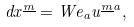Convert formula to latex. <formula><loc_0><loc_0><loc_500><loc_500>d x ^ { \underline { m } } = W e _ { a } u ^ { { \underline { m } } a } ,</formula> 